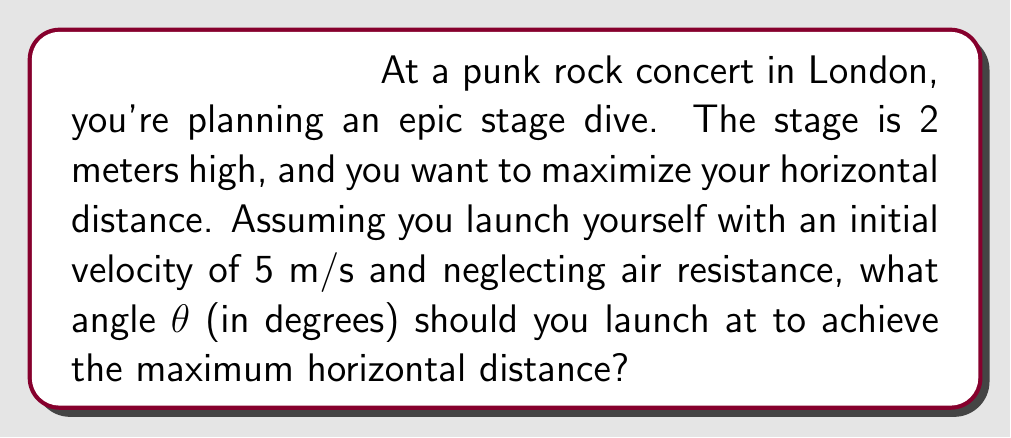Can you answer this question? Let's approach this step-by-step using projectile motion equations:

1) The horizontal distance (range) for a projectile launched from height h is given by:

   $$R = v_0 \cos(\theta) \left(\frac{v_0 \sin(\theta) + \sqrt{(v_0 \sin(\theta))^2 + 2gh}}{g}\right)$$

   Where $v_0$ is initial velocity, θ is launch angle, g is acceleration due to gravity (9.8 m/s²), and h is initial height.

2) To find the maximum, we need to differentiate R with respect to θ and set it to zero. However, this leads to a complicated equation.

3) For a simpler approach, we can use the fact that for projectile motion from ground level, the optimal angle is 45°. When launching from a height, the optimal angle is slightly less than 45°.

4) A good approximation for the optimal angle from a height is:

   $$\theta_{opt} \approx 45° - \frac{1}{2}\arctan\left(\frac{4h}{R_0}\right)$$

   Where $R_0$ is the range when launched at 45° from ground level.

5) Calculate $R_0$:
   $$R_0 = \frac{v_0^2}{g} = \frac{5^2}{9.8} \approx 2.55\text{ m}$$

6) Now we can calculate θ:
   $$\theta_{opt} \approx 45° - \frac{1}{2}\arctan\left(\frac{4 \cdot 2}{2.55}\right)$$
   $$\theta_{opt} \approx 45° - \frac{1}{2}\arctan(3.14)$$
   $$\theta_{opt} \approx 45° - 28.8°$$
   $$\theta_{opt} \approx 36.2°$$

7) Rounding to the nearest degree: θ ≈ 36°
Answer: 36° 